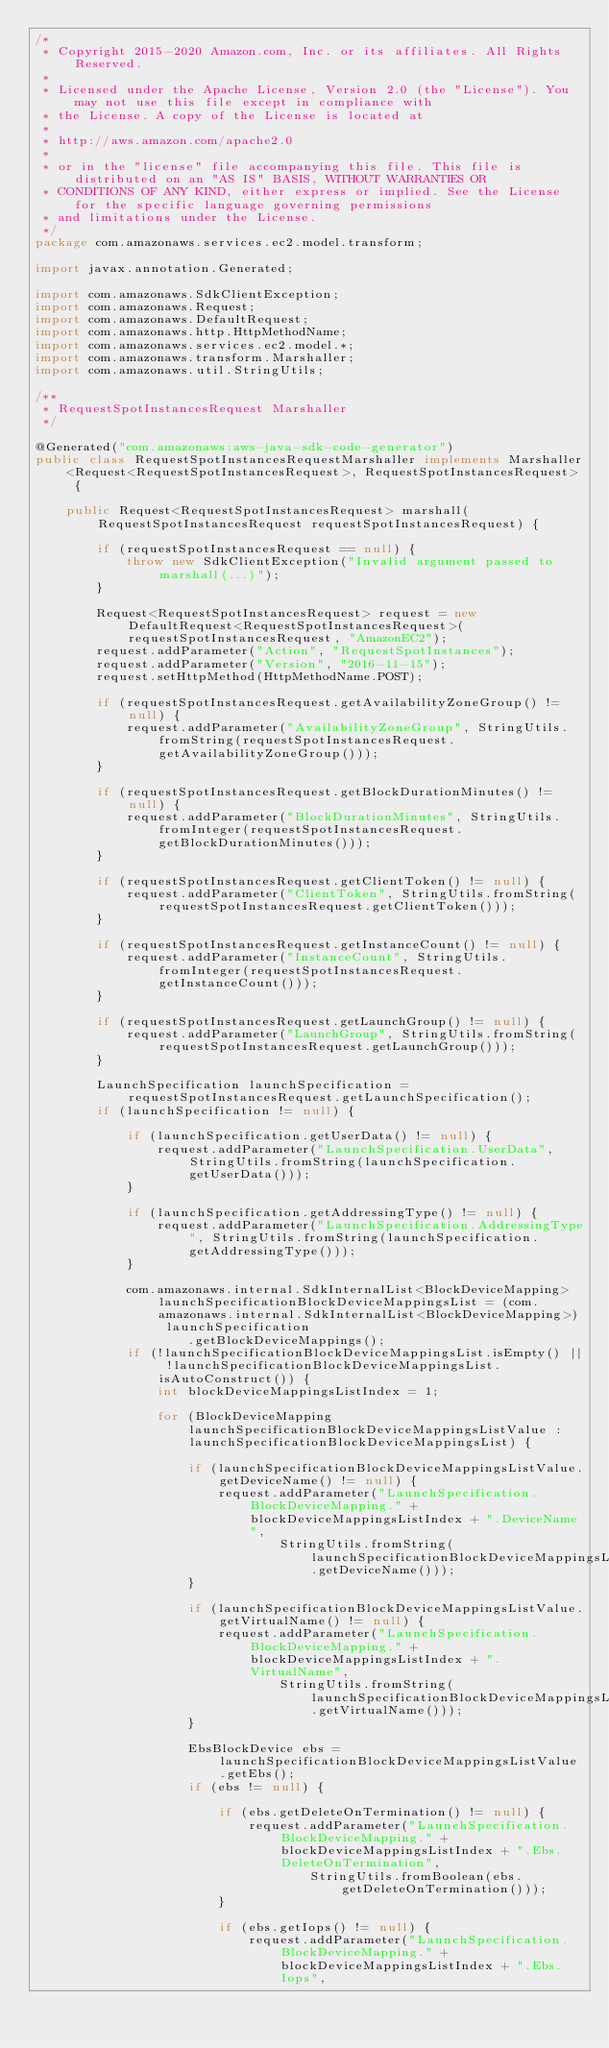Convert code to text. <code><loc_0><loc_0><loc_500><loc_500><_Java_>/*
 * Copyright 2015-2020 Amazon.com, Inc. or its affiliates. All Rights Reserved.
 * 
 * Licensed under the Apache License, Version 2.0 (the "License"). You may not use this file except in compliance with
 * the License. A copy of the License is located at
 * 
 * http://aws.amazon.com/apache2.0
 * 
 * or in the "license" file accompanying this file. This file is distributed on an "AS IS" BASIS, WITHOUT WARRANTIES OR
 * CONDITIONS OF ANY KIND, either express or implied. See the License for the specific language governing permissions
 * and limitations under the License.
 */
package com.amazonaws.services.ec2.model.transform;

import javax.annotation.Generated;

import com.amazonaws.SdkClientException;
import com.amazonaws.Request;
import com.amazonaws.DefaultRequest;
import com.amazonaws.http.HttpMethodName;
import com.amazonaws.services.ec2.model.*;
import com.amazonaws.transform.Marshaller;
import com.amazonaws.util.StringUtils;

/**
 * RequestSpotInstancesRequest Marshaller
 */

@Generated("com.amazonaws:aws-java-sdk-code-generator")
public class RequestSpotInstancesRequestMarshaller implements Marshaller<Request<RequestSpotInstancesRequest>, RequestSpotInstancesRequest> {

    public Request<RequestSpotInstancesRequest> marshall(RequestSpotInstancesRequest requestSpotInstancesRequest) {

        if (requestSpotInstancesRequest == null) {
            throw new SdkClientException("Invalid argument passed to marshall(...)");
        }

        Request<RequestSpotInstancesRequest> request = new DefaultRequest<RequestSpotInstancesRequest>(requestSpotInstancesRequest, "AmazonEC2");
        request.addParameter("Action", "RequestSpotInstances");
        request.addParameter("Version", "2016-11-15");
        request.setHttpMethod(HttpMethodName.POST);

        if (requestSpotInstancesRequest.getAvailabilityZoneGroup() != null) {
            request.addParameter("AvailabilityZoneGroup", StringUtils.fromString(requestSpotInstancesRequest.getAvailabilityZoneGroup()));
        }

        if (requestSpotInstancesRequest.getBlockDurationMinutes() != null) {
            request.addParameter("BlockDurationMinutes", StringUtils.fromInteger(requestSpotInstancesRequest.getBlockDurationMinutes()));
        }

        if (requestSpotInstancesRequest.getClientToken() != null) {
            request.addParameter("ClientToken", StringUtils.fromString(requestSpotInstancesRequest.getClientToken()));
        }

        if (requestSpotInstancesRequest.getInstanceCount() != null) {
            request.addParameter("InstanceCount", StringUtils.fromInteger(requestSpotInstancesRequest.getInstanceCount()));
        }

        if (requestSpotInstancesRequest.getLaunchGroup() != null) {
            request.addParameter("LaunchGroup", StringUtils.fromString(requestSpotInstancesRequest.getLaunchGroup()));
        }

        LaunchSpecification launchSpecification = requestSpotInstancesRequest.getLaunchSpecification();
        if (launchSpecification != null) {

            if (launchSpecification.getUserData() != null) {
                request.addParameter("LaunchSpecification.UserData", StringUtils.fromString(launchSpecification.getUserData()));
            }

            if (launchSpecification.getAddressingType() != null) {
                request.addParameter("LaunchSpecification.AddressingType", StringUtils.fromString(launchSpecification.getAddressingType()));
            }

            com.amazonaws.internal.SdkInternalList<BlockDeviceMapping> launchSpecificationBlockDeviceMappingsList = (com.amazonaws.internal.SdkInternalList<BlockDeviceMapping>) launchSpecification
                    .getBlockDeviceMappings();
            if (!launchSpecificationBlockDeviceMappingsList.isEmpty() || !launchSpecificationBlockDeviceMappingsList.isAutoConstruct()) {
                int blockDeviceMappingsListIndex = 1;

                for (BlockDeviceMapping launchSpecificationBlockDeviceMappingsListValue : launchSpecificationBlockDeviceMappingsList) {

                    if (launchSpecificationBlockDeviceMappingsListValue.getDeviceName() != null) {
                        request.addParameter("LaunchSpecification.BlockDeviceMapping." + blockDeviceMappingsListIndex + ".DeviceName",
                                StringUtils.fromString(launchSpecificationBlockDeviceMappingsListValue.getDeviceName()));
                    }

                    if (launchSpecificationBlockDeviceMappingsListValue.getVirtualName() != null) {
                        request.addParameter("LaunchSpecification.BlockDeviceMapping." + blockDeviceMappingsListIndex + ".VirtualName",
                                StringUtils.fromString(launchSpecificationBlockDeviceMappingsListValue.getVirtualName()));
                    }

                    EbsBlockDevice ebs = launchSpecificationBlockDeviceMappingsListValue.getEbs();
                    if (ebs != null) {

                        if (ebs.getDeleteOnTermination() != null) {
                            request.addParameter("LaunchSpecification.BlockDeviceMapping." + blockDeviceMappingsListIndex + ".Ebs.DeleteOnTermination",
                                    StringUtils.fromBoolean(ebs.getDeleteOnTermination()));
                        }

                        if (ebs.getIops() != null) {
                            request.addParameter("LaunchSpecification.BlockDeviceMapping." + blockDeviceMappingsListIndex + ".Ebs.Iops",</code> 